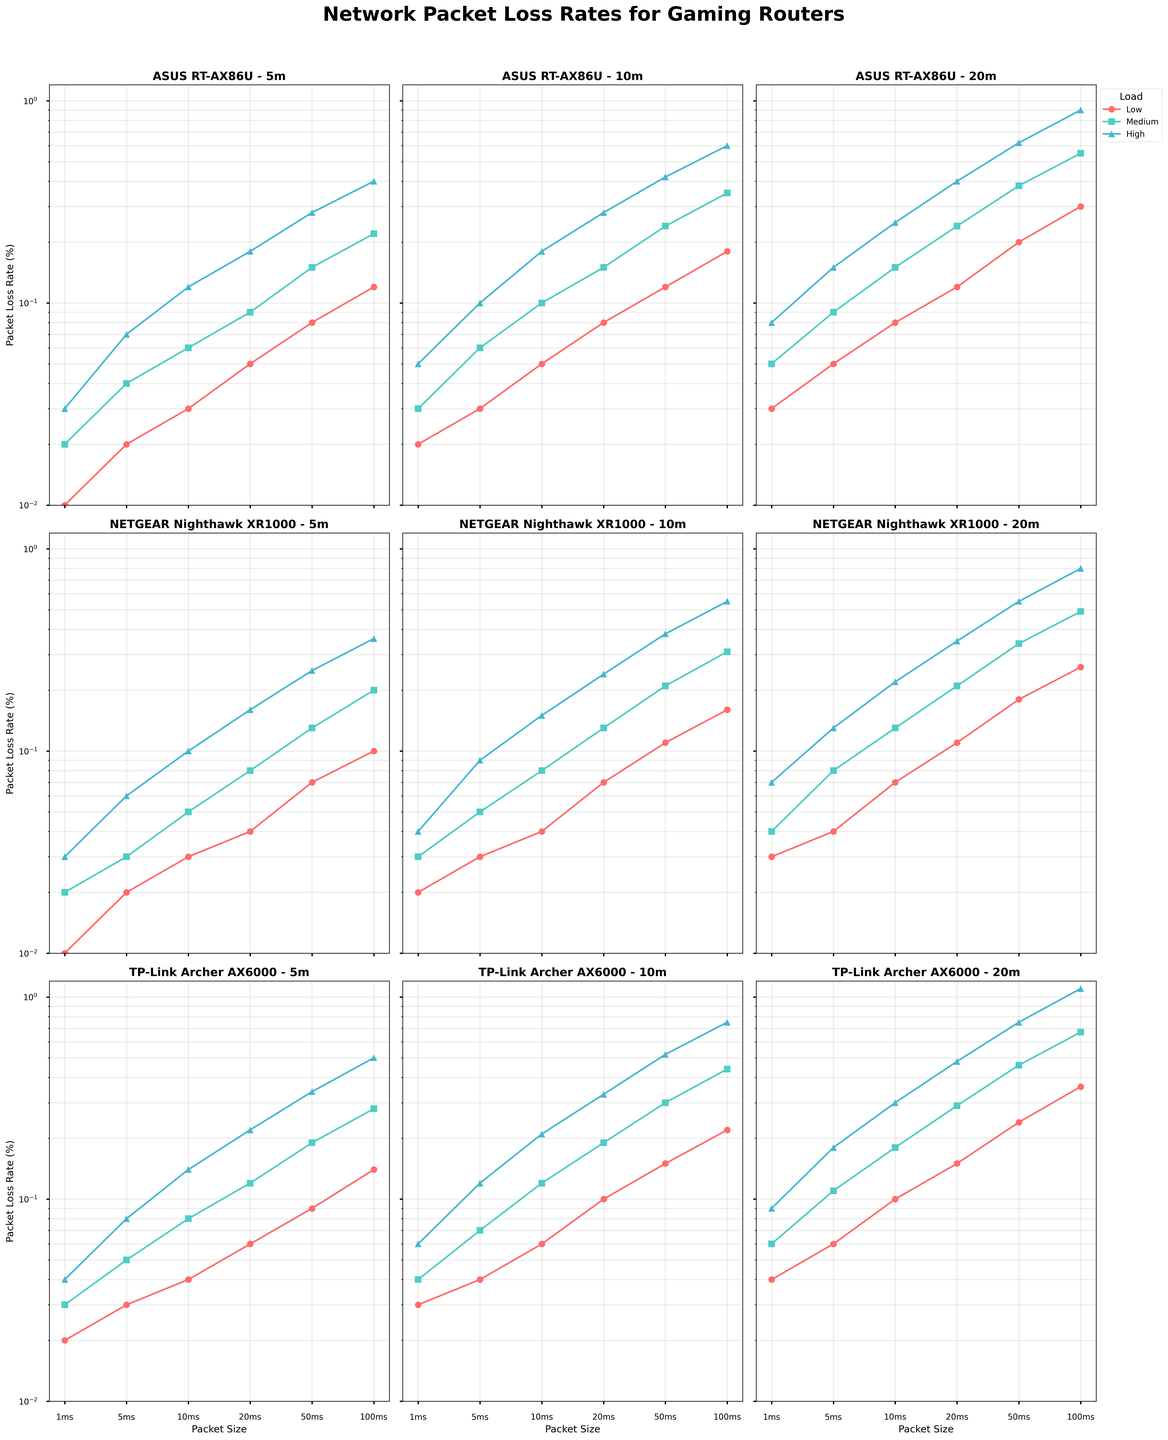Which router has the lowest packet loss rate at 5 meters under high load for 100ms packets? Look at the subplots for 100ms packet sizes at 5 meters distance under high load. The NETGEAR Nighthawk XR1000 shows the lowest value at 0.36% compared to the others.
Answer: NETGEAR Nighthawk XR1000 Which router has the highest packet loss rate at 20 meters under medium load for 50ms packets? Look at the subplots for 50ms packet sizes at 20 meters distance under medium load. The TP-Link Archer AX6000 has the highest value at 0.46% compared to the others.
Answer: TP-Link Archer AX6000 What is the difference in packet loss rate between the TP-Link Archer AX6000 and ASUS RT-AX86U at 10 meters under low load for 20ms packets? Look at the subplots for 20ms packet sizes at 10 meters distance under low load. The packet loss rate for TP-Link Archer AX6000 is 0.10% and for ASUS RT-AX86U is 0.08%, so the difference is 0.10% - 0.08% = 0.02%.
Answer: 0.02% Which load condition generally results in the highest packet loss rates across all routers and distances? Look at all the subplots across different routers and distances. The high load consistently results in the highest packet loss rates compared to low and medium loads.
Answer: High load On average, which packet size and router combination at 5 meters results in the lowest packet loss rate? Calculate the average packet loss rate for each router at 5 meters across all packet sizes, then identify the combination with the lowest average. The NETGEAR Nighthawk XR1000 consistently has low packet loss rates, and 1ms packets have the lowest individual rates.
Answer: 1ms packets, NETGEAR Nighthawk XR1000 How does the packet loss rate for the ASUS RT-AX86U at 10 meters under high load for 10ms packets compare to the TP-Link Archer AX6000 at the same conditions? Look at the subplots for 10ms packet sizes at 10 meters under high load. The ASUS RT-AX86U has a packet loss rate of 0.18%, while the TP-Link Archer AX6000 has a packet loss rate of 0.21%. The ASUS RT-AX86U shows a lower rate.
Answer: ASUS RT-AX86U has a lower rate Under medium load, which router shows the least increase in packet loss rate when moving from 5 meters to 20 meters for 50ms packets? Look at the data for 50ms packets under medium load. Compute the increase from 5 meters to 20 meters for each router. The NETGEAR Nighthawk XR1000 shows an increase from 0.13% to 0.34%, which is the smallest increase compared to other routers.
Answer: NETGEAR Nighthawk XR1000 What is the combined packet loss rate for the ASUS RT-AX86U at 5 meters under low load for 1ms and 10ms packets? Look at the subplot for 5 meters under low load. For 1ms packets, the rate is 0.01%, and for 10ms packets, the rate is 0.03%. So, the combined packet loss rate is 0.01% + 0.03% = 0.04%.
Answer: 0.04% 